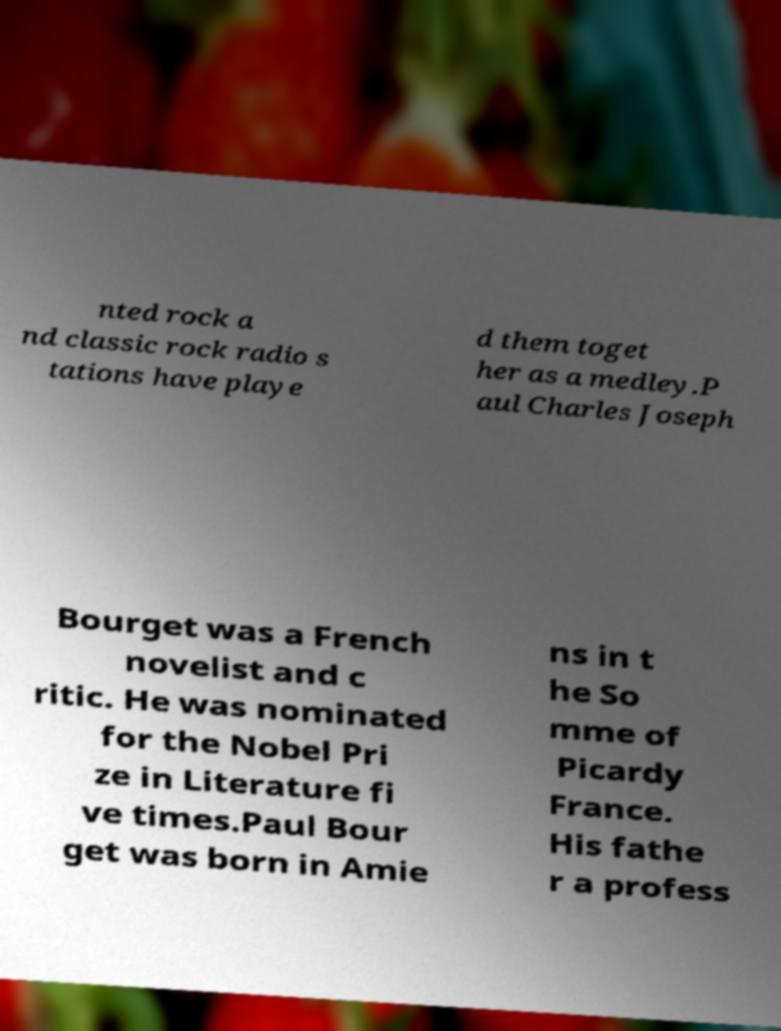Can you accurately transcribe the text from the provided image for me? nted rock a nd classic rock radio s tations have playe d them toget her as a medley.P aul Charles Joseph Bourget was a French novelist and c ritic. He was nominated for the Nobel Pri ze in Literature fi ve times.Paul Bour get was born in Amie ns in t he So mme of Picardy France. His fathe r a profess 